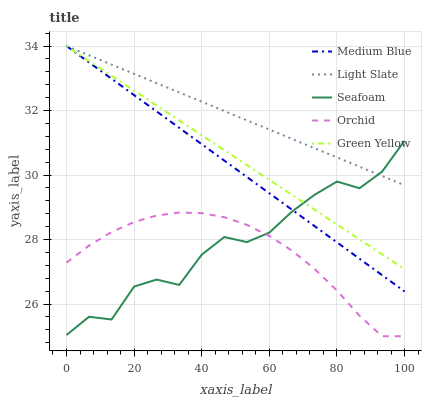Does Green Yellow have the minimum area under the curve?
Answer yes or no. No. Does Green Yellow have the maximum area under the curve?
Answer yes or no. No. Is Green Yellow the smoothest?
Answer yes or no. No. Is Green Yellow the roughest?
Answer yes or no. No. Does Green Yellow have the lowest value?
Answer yes or no. No. Does Seafoam have the highest value?
Answer yes or no. No. Is Orchid less than Medium Blue?
Answer yes or no. Yes. Is Light Slate greater than Orchid?
Answer yes or no. Yes. Does Orchid intersect Medium Blue?
Answer yes or no. No. 